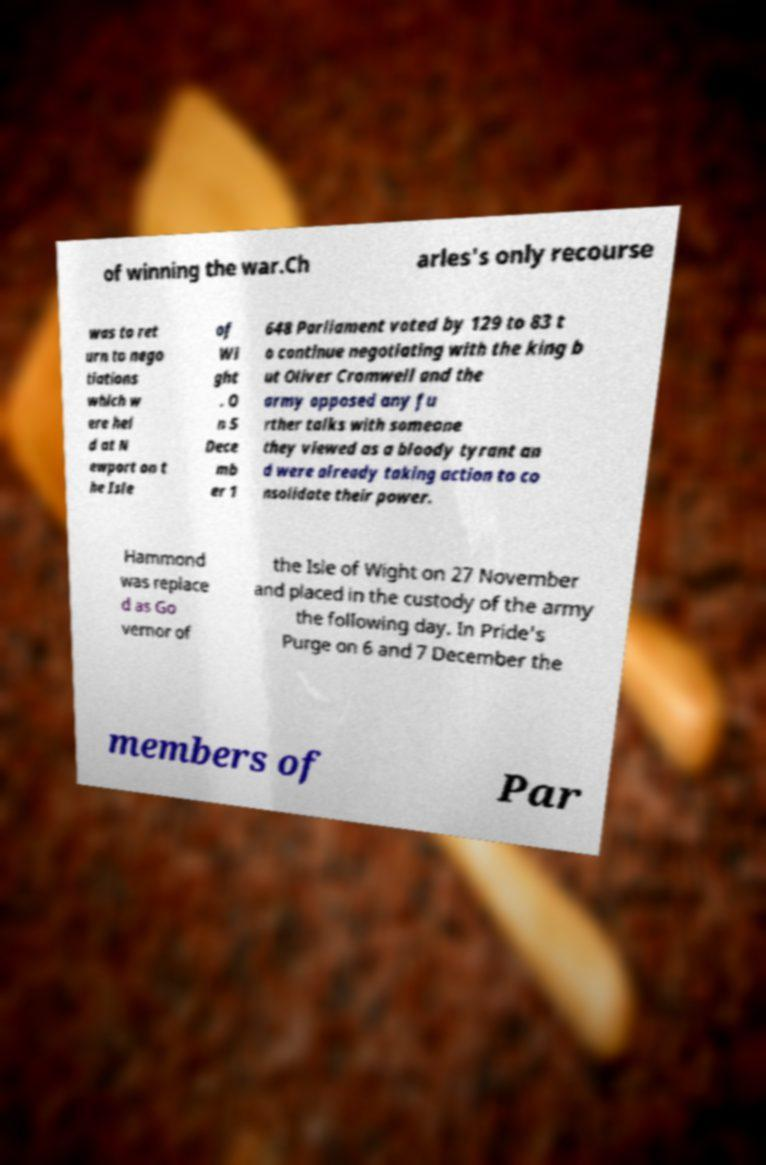Can you accurately transcribe the text from the provided image for me? of winning the war.Ch arles's only recourse was to ret urn to nego tiations which w ere hel d at N ewport on t he Isle of Wi ght . O n 5 Dece mb er 1 648 Parliament voted by 129 to 83 t o continue negotiating with the king b ut Oliver Cromwell and the army opposed any fu rther talks with someone they viewed as a bloody tyrant an d were already taking action to co nsolidate their power. Hammond was replace d as Go vernor of the Isle of Wight on 27 November and placed in the custody of the army the following day. In Pride's Purge on 6 and 7 December the members of Par 